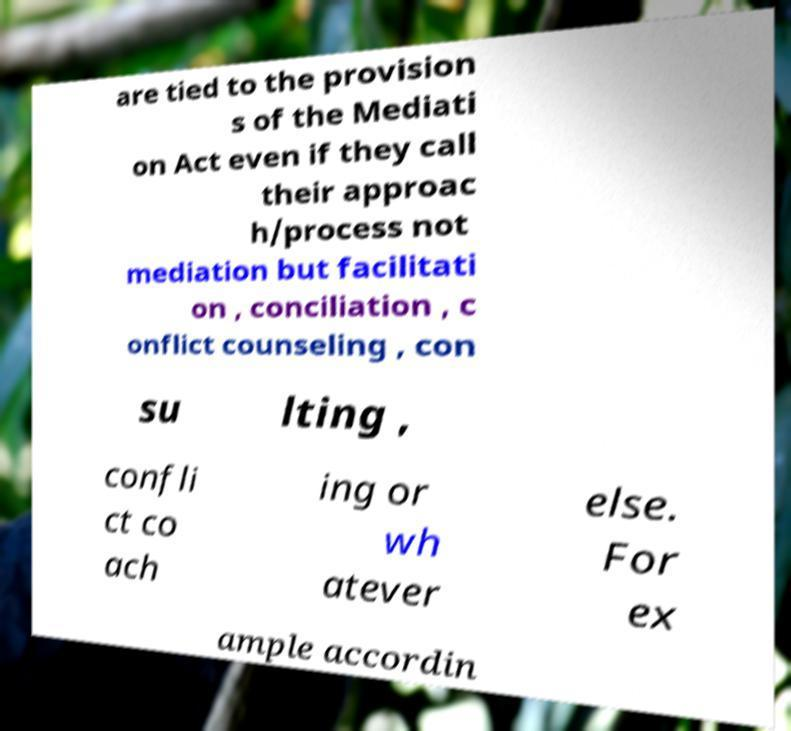Please read and relay the text visible in this image. What does it say? are tied to the provision s of the Mediati on Act even if they call their approac h/process not mediation but facilitati on , conciliation , c onflict counseling , con su lting , confli ct co ach ing or wh atever else. For ex ample accordin 